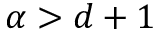<formula> <loc_0><loc_0><loc_500><loc_500>\alpha > d + 1</formula> 